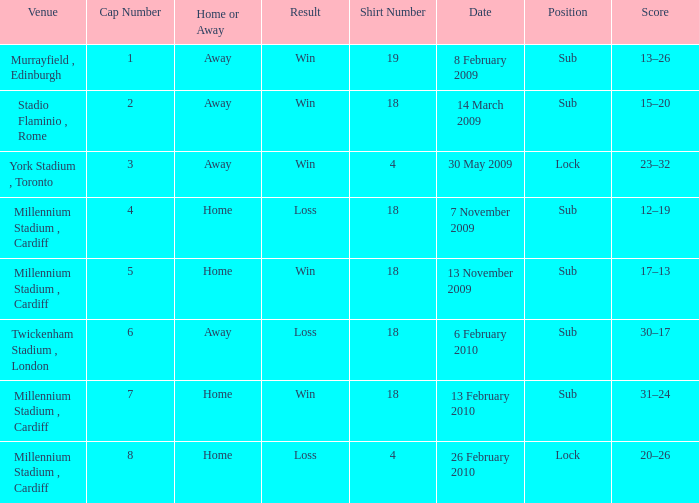Can you tell me the Score that has the Result of win, and the Date of 13 november 2009? 17–13. 